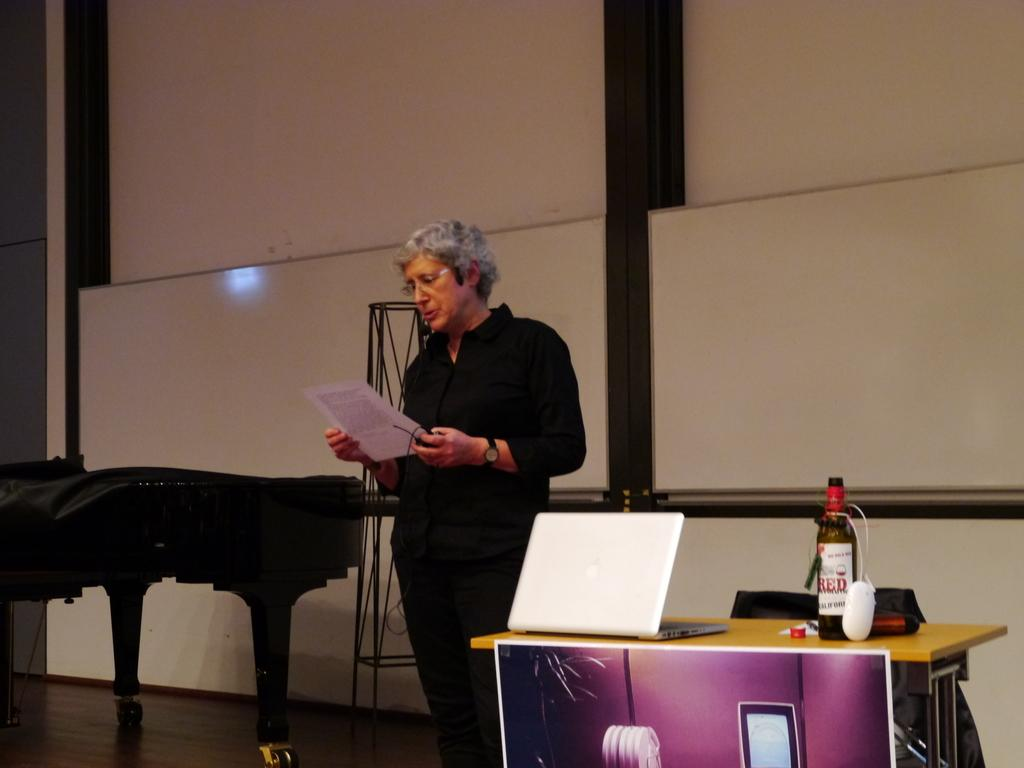What is the woman in the image doing? The woman is standing in the image and reading something on a paper. What is the woman holding in her hands? The woman is holding a paper in her hands. What objects can be seen on the table in the image? There is a bottle and a laptop on the table in the image. What type of arithmetic problem is the woman solving on the paper? There is no indication in the image that the woman is solving an arithmetic problem on the paper. Can you see any blood on the woman or the objects in the image? There is no blood visible in the image. 